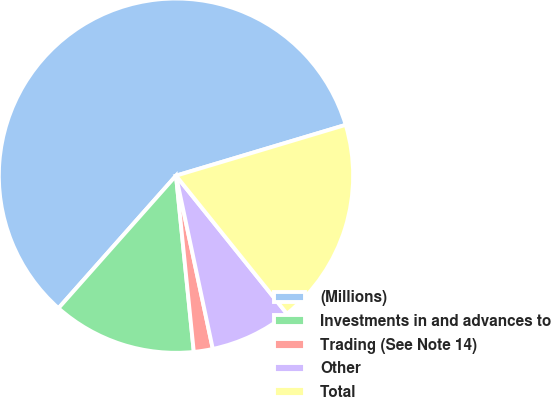Convert chart. <chart><loc_0><loc_0><loc_500><loc_500><pie_chart><fcel>(Millions)<fcel>Investments in and advances to<fcel>Trading (See Note 14)<fcel>Other<fcel>Total<nl><fcel>58.83%<fcel>13.15%<fcel>1.73%<fcel>7.44%<fcel>18.86%<nl></chart> 